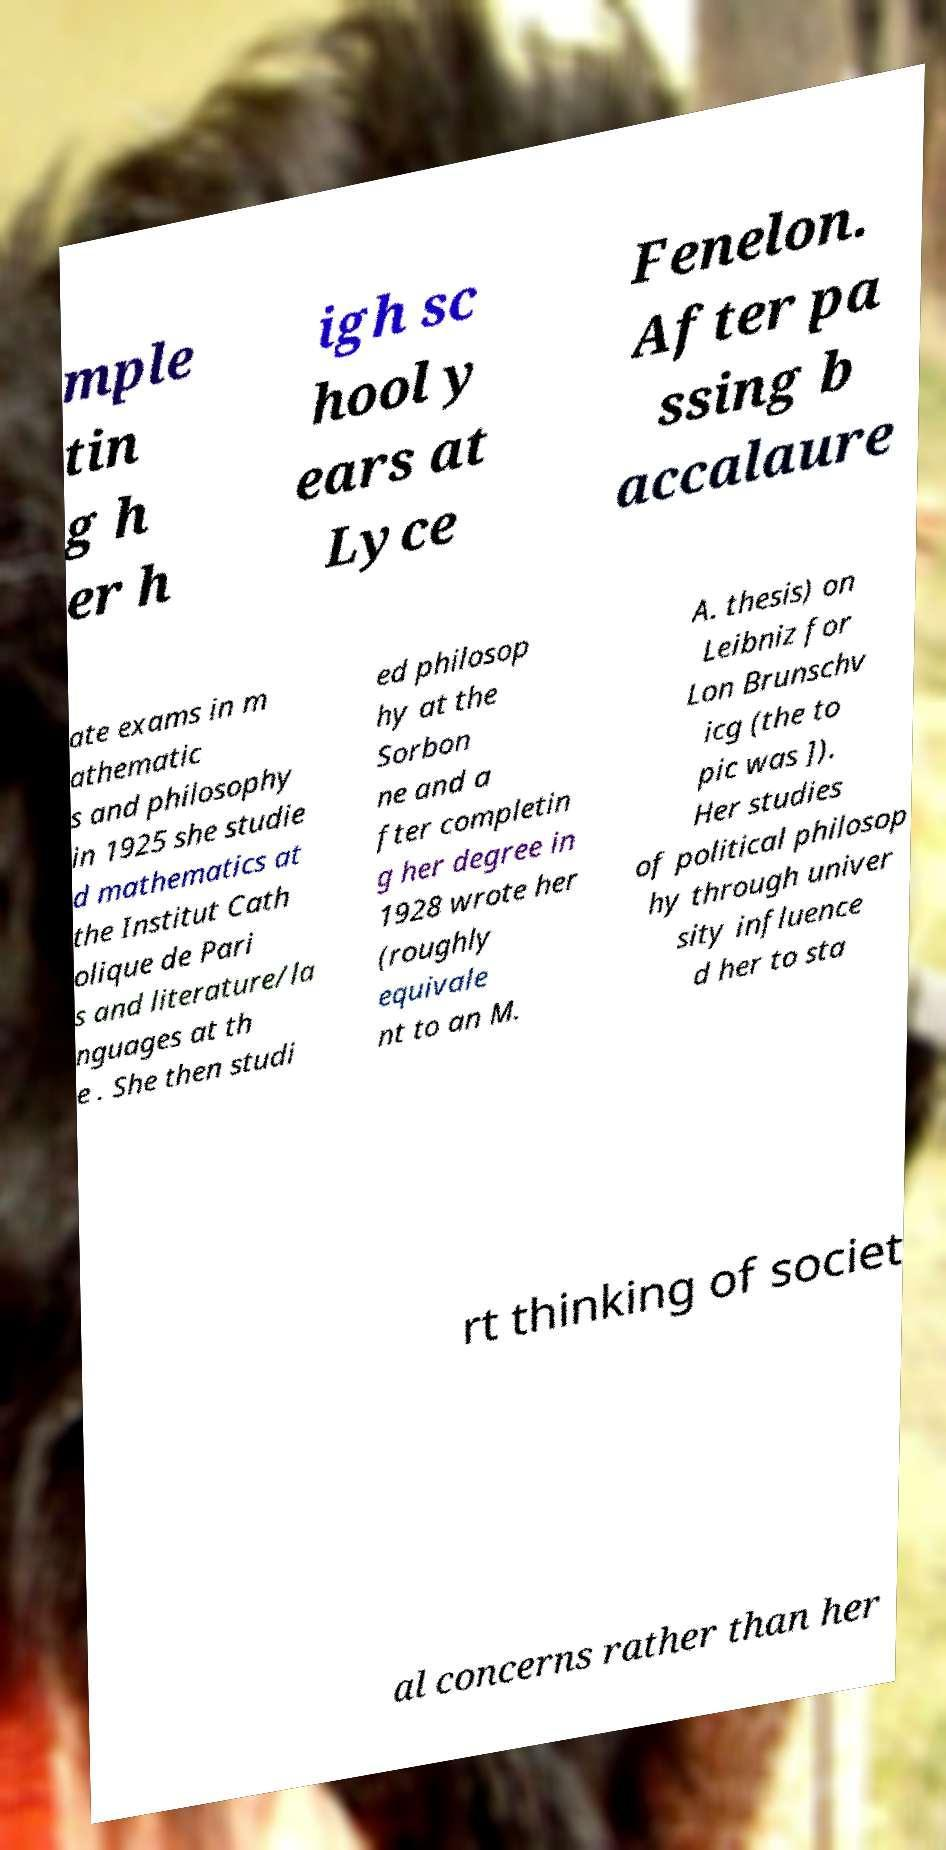There's text embedded in this image that I need extracted. Can you transcribe it verbatim? mple tin g h er h igh sc hool y ears at Lyce Fenelon. After pa ssing b accalaure ate exams in m athematic s and philosophy in 1925 she studie d mathematics at the Institut Cath olique de Pari s and literature/la nguages at th e . She then studi ed philosop hy at the Sorbon ne and a fter completin g her degree in 1928 wrote her (roughly equivale nt to an M. A. thesis) on Leibniz for Lon Brunschv icg (the to pic was ]). Her studies of political philosop hy through univer sity influence d her to sta rt thinking of societ al concerns rather than her 